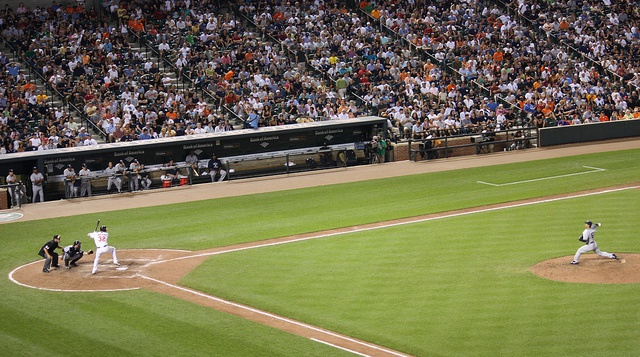Describe the objects in this image and their specific colors. I can see people in black, gray, maroon, and darkgray tones, bench in black, gray, and darkgray tones, people in black, lavender, olive, darkgray, and gray tones, people in black, olive, lightgray, darkgray, and gray tones, and people in black, gray, and tan tones in this image. 